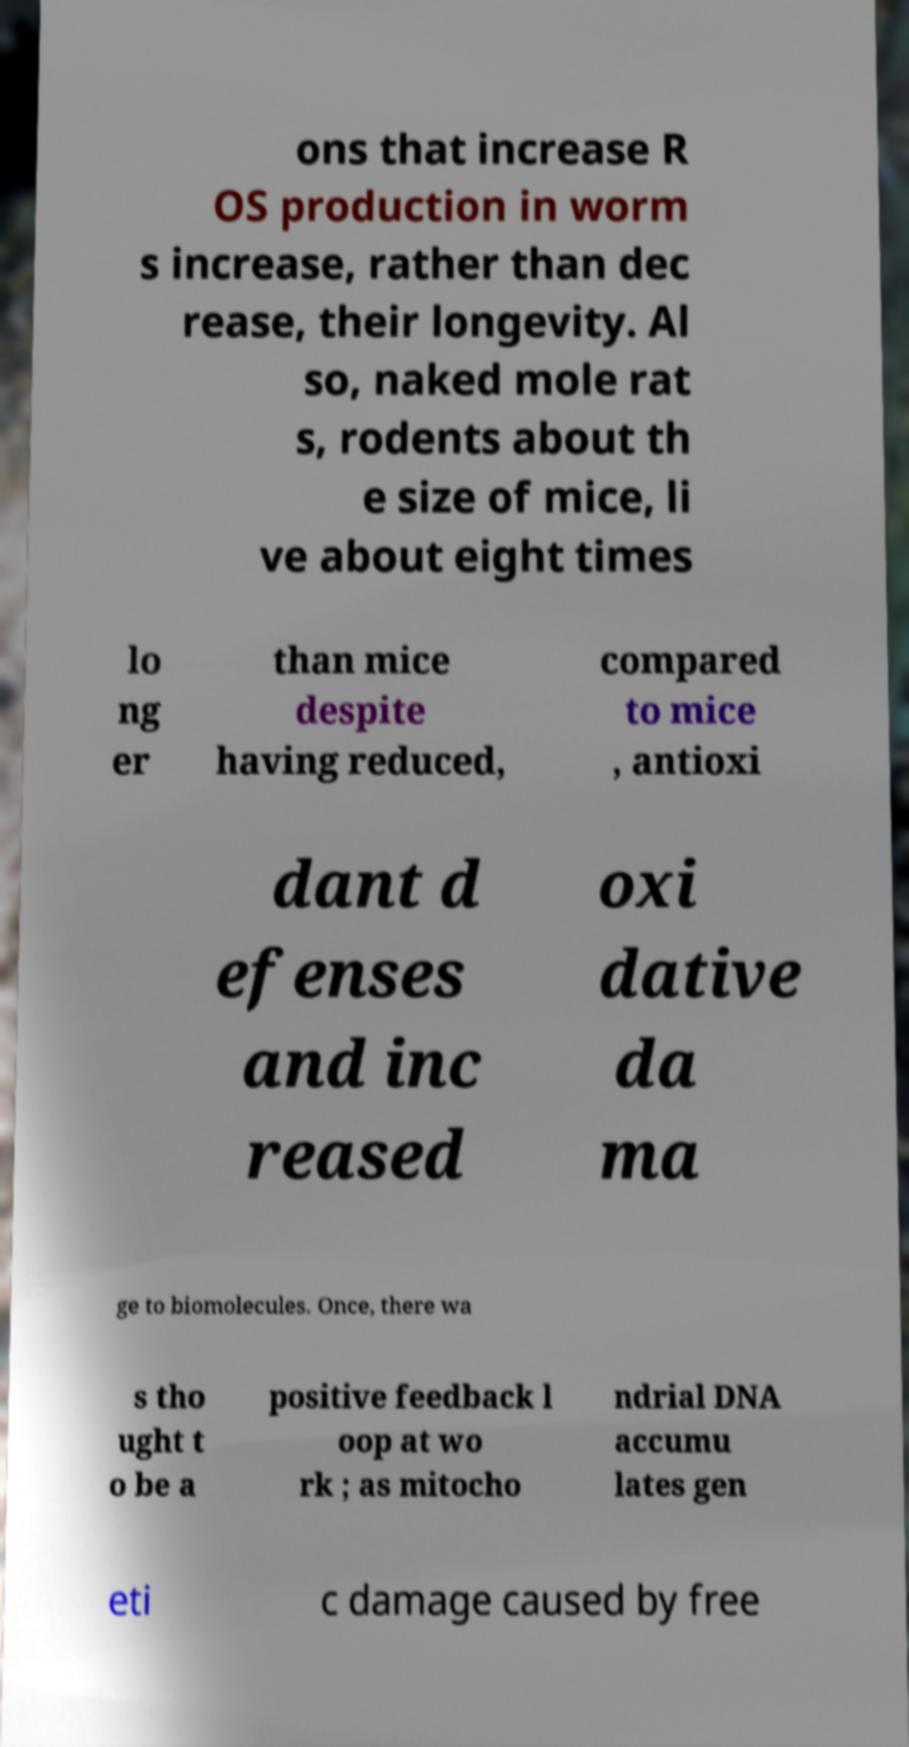Can you accurately transcribe the text from the provided image for me? ons that increase R OS production in worm s increase, rather than dec rease, their longevity. Al so, naked mole rat s, rodents about th e size of mice, li ve about eight times lo ng er than mice despite having reduced, compared to mice , antioxi dant d efenses and inc reased oxi dative da ma ge to biomolecules. Once, there wa s tho ught t o be a positive feedback l oop at wo rk ; as mitocho ndrial DNA accumu lates gen eti c damage caused by free 